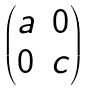<formula> <loc_0><loc_0><loc_500><loc_500>\begin{pmatrix} a & 0 \\ 0 & c \end{pmatrix}</formula> 